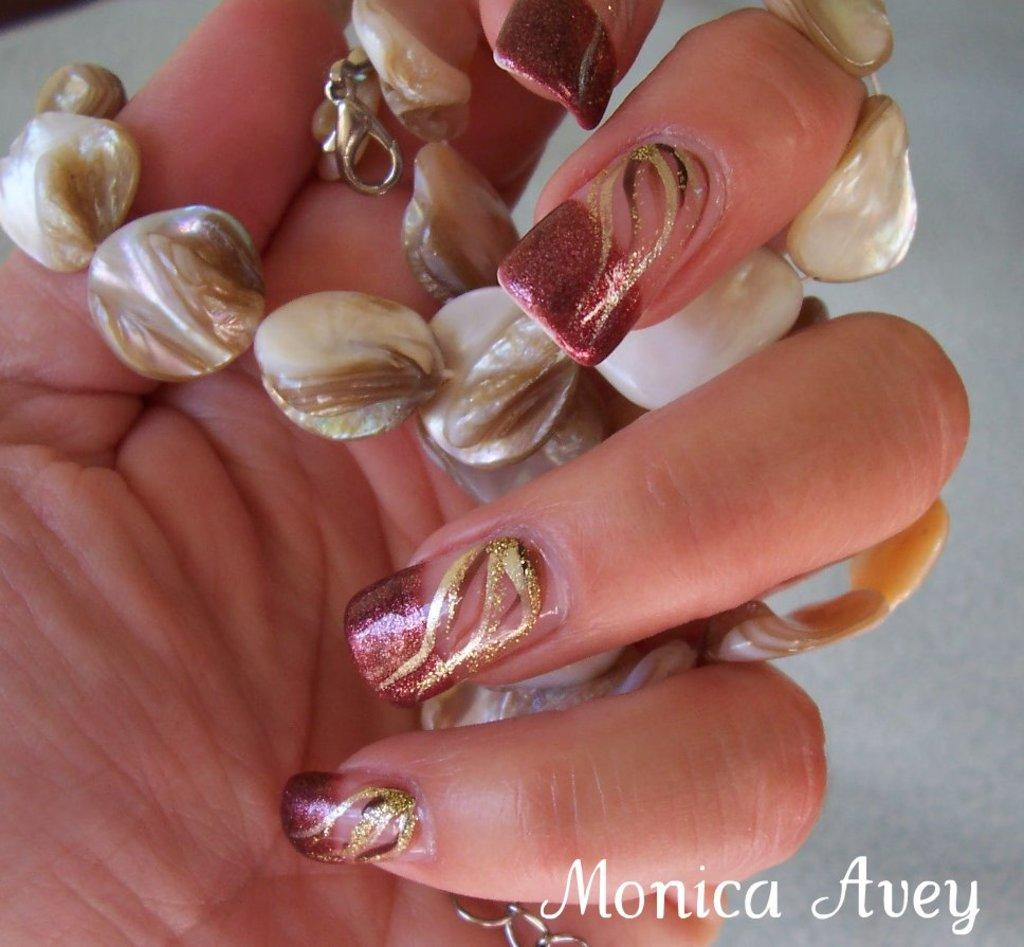<image>
Offer a succinct explanation of the picture presented. The nail polish picture is made by Monica Avey. 